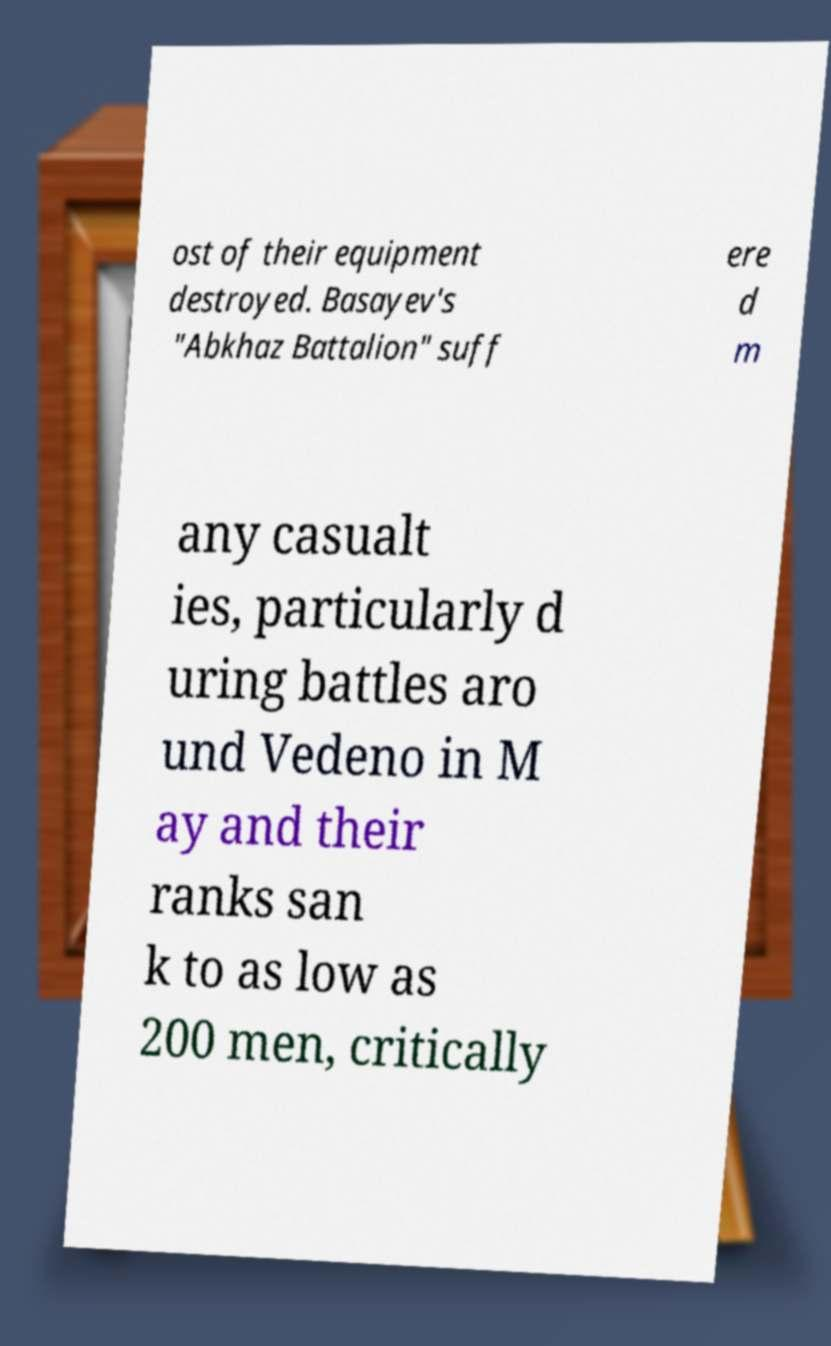Please identify and transcribe the text found in this image. ost of their equipment destroyed. Basayev's "Abkhaz Battalion" suff ere d m any casualt ies, particularly d uring battles aro und Vedeno in M ay and their ranks san k to as low as 200 men, critically 